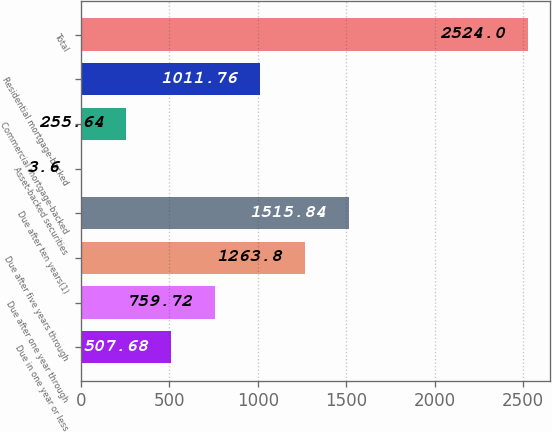Convert chart. <chart><loc_0><loc_0><loc_500><loc_500><bar_chart><fcel>Due in one year or less<fcel>Due after one year through<fcel>Due after five years through<fcel>Due after ten years(1)<fcel>Asset-backed securities<fcel>Commercial mortgage-backed<fcel>Residential mortgage-backed<fcel>Total<nl><fcel>507.68<fcel>759.72<fcel>1263.8<fcel>1515.84<fcel>3.6<fcel>255.64<fcel>1011.76<fcel>2524<nl></chart> 